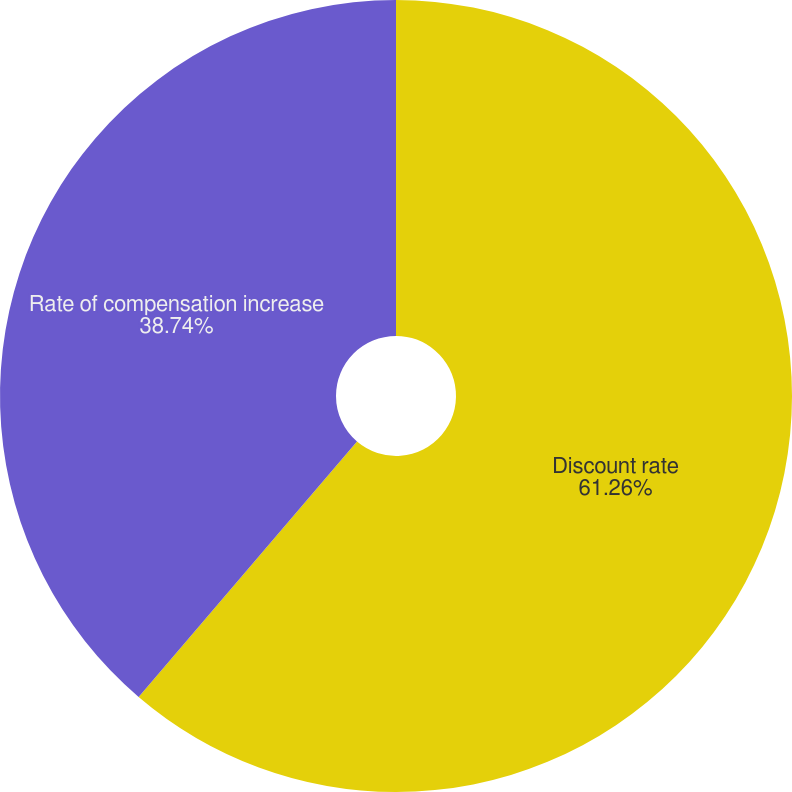Convert chart. <chart><loc_0><loc_0><loc_500><loc_500><pie_chart><fcel>Discount rate<fcel>Rate of compensation increase<nl><fcel>61.26%<fcel>38.74%<nl></chart> 